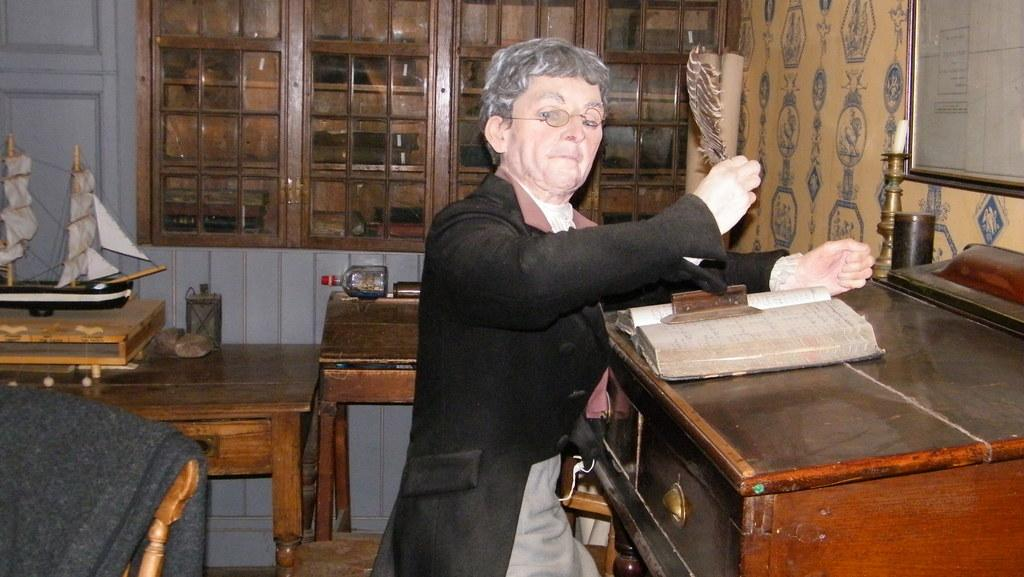Who is present in the image? There is a man in the image. What object is on the table in front of the man? There is a book on a table in front of the man. What is located behind the man in the image? There is a miniature behind the man. How many trucks are visible in the image? There are no trucks present in the image. What type of yoke is being used by the man in the image? There is no yoke present in the image, and the man is not performing any activity that would require a yoke. 